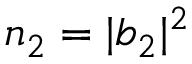Convert formula to latex. <formula><loc_0><loc_0><loc_500><loc_500>n _ { 2 } = | b _ { 2 } | ^ { 2 }</formula> 